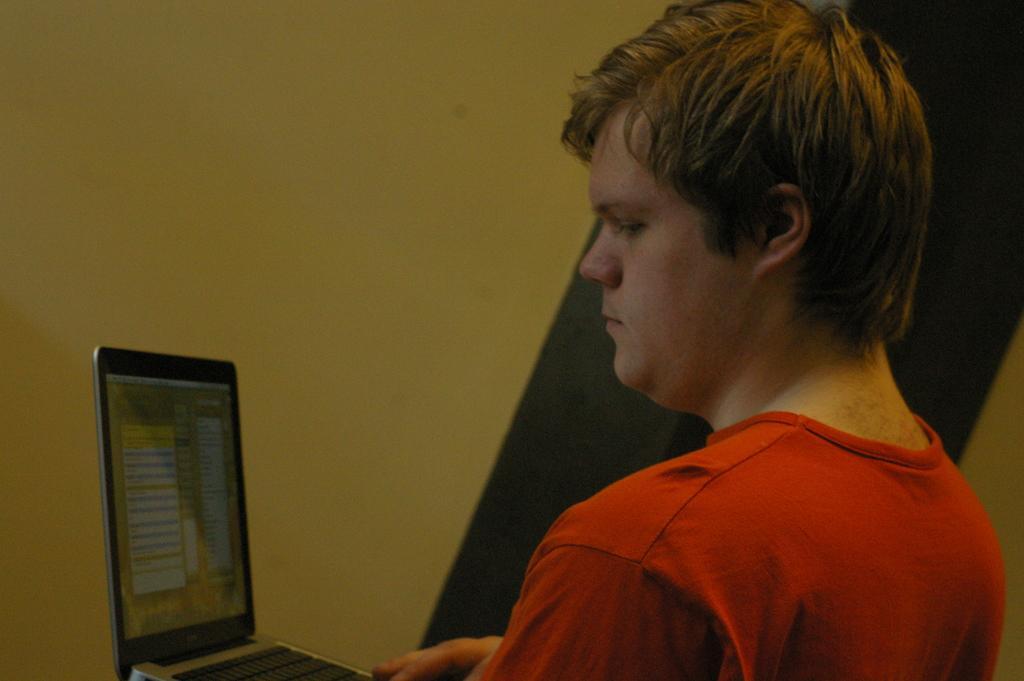Can you describe this image briefly? In this image we can see a person wearing the t shirt and also holding the laptop. In the background we can see the wall. 